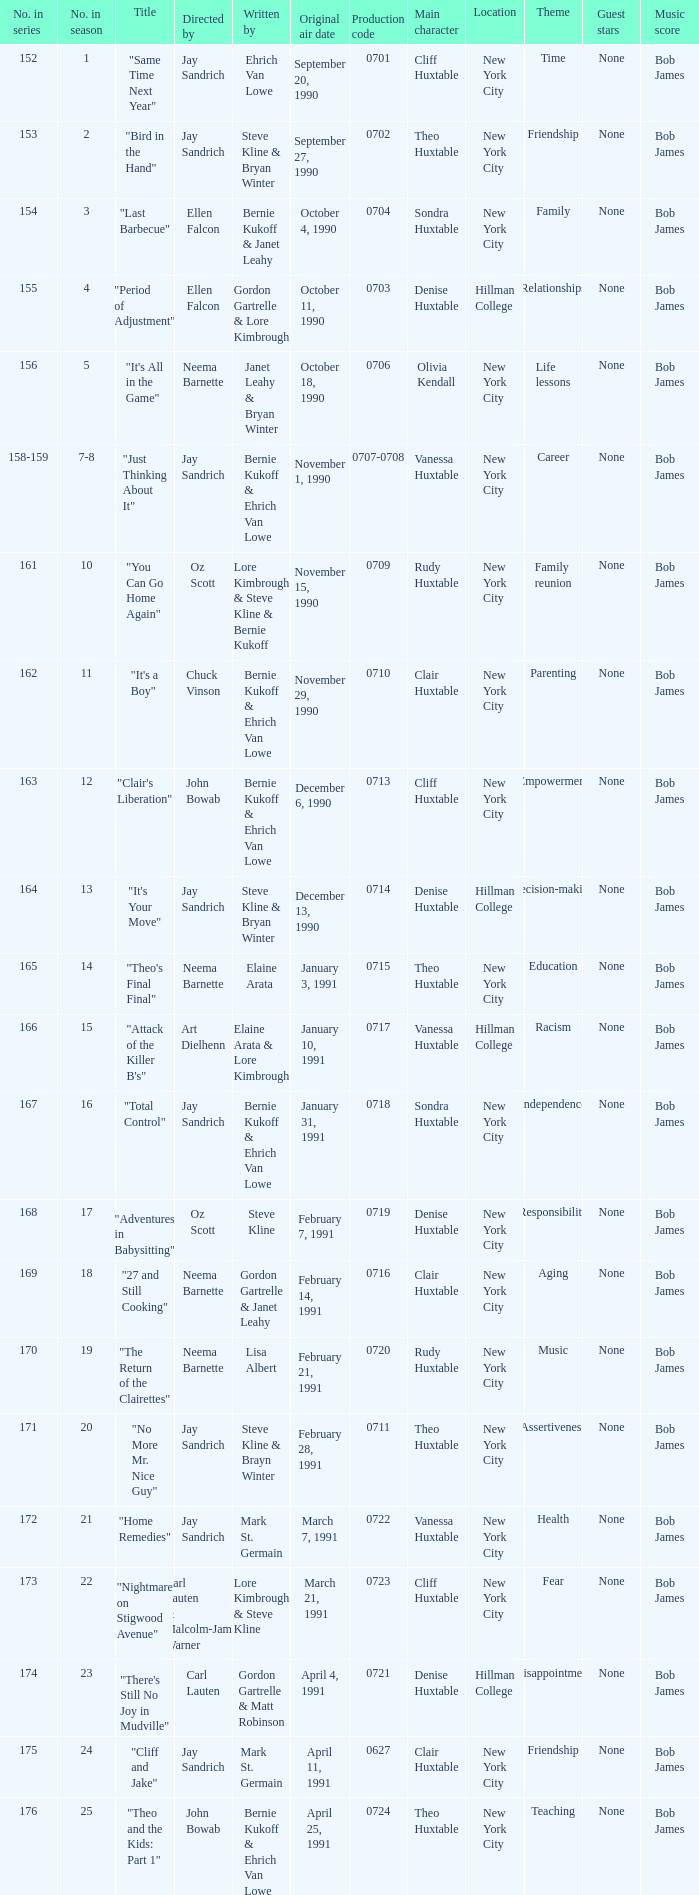Who directed the episode entitled "it's your move"? Jay Sandrich. 